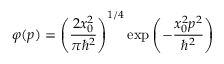Convert formula to latex. <formula><loc_0><loc_0><loc_500><loc_500>\varphi ( p ) = \left ( { \frac { 2 x _ { 0 } ^ { 2 } } { \pi \hbar { ^ } { 2 } } } \right ) ^ { 1 / 4 } \exp { \left ( - { \frac { x _ { 0 } ^ { 2 } p ^ { 2 } } { \hbar { ^ } { 2 } } } \right ) }</formula> 